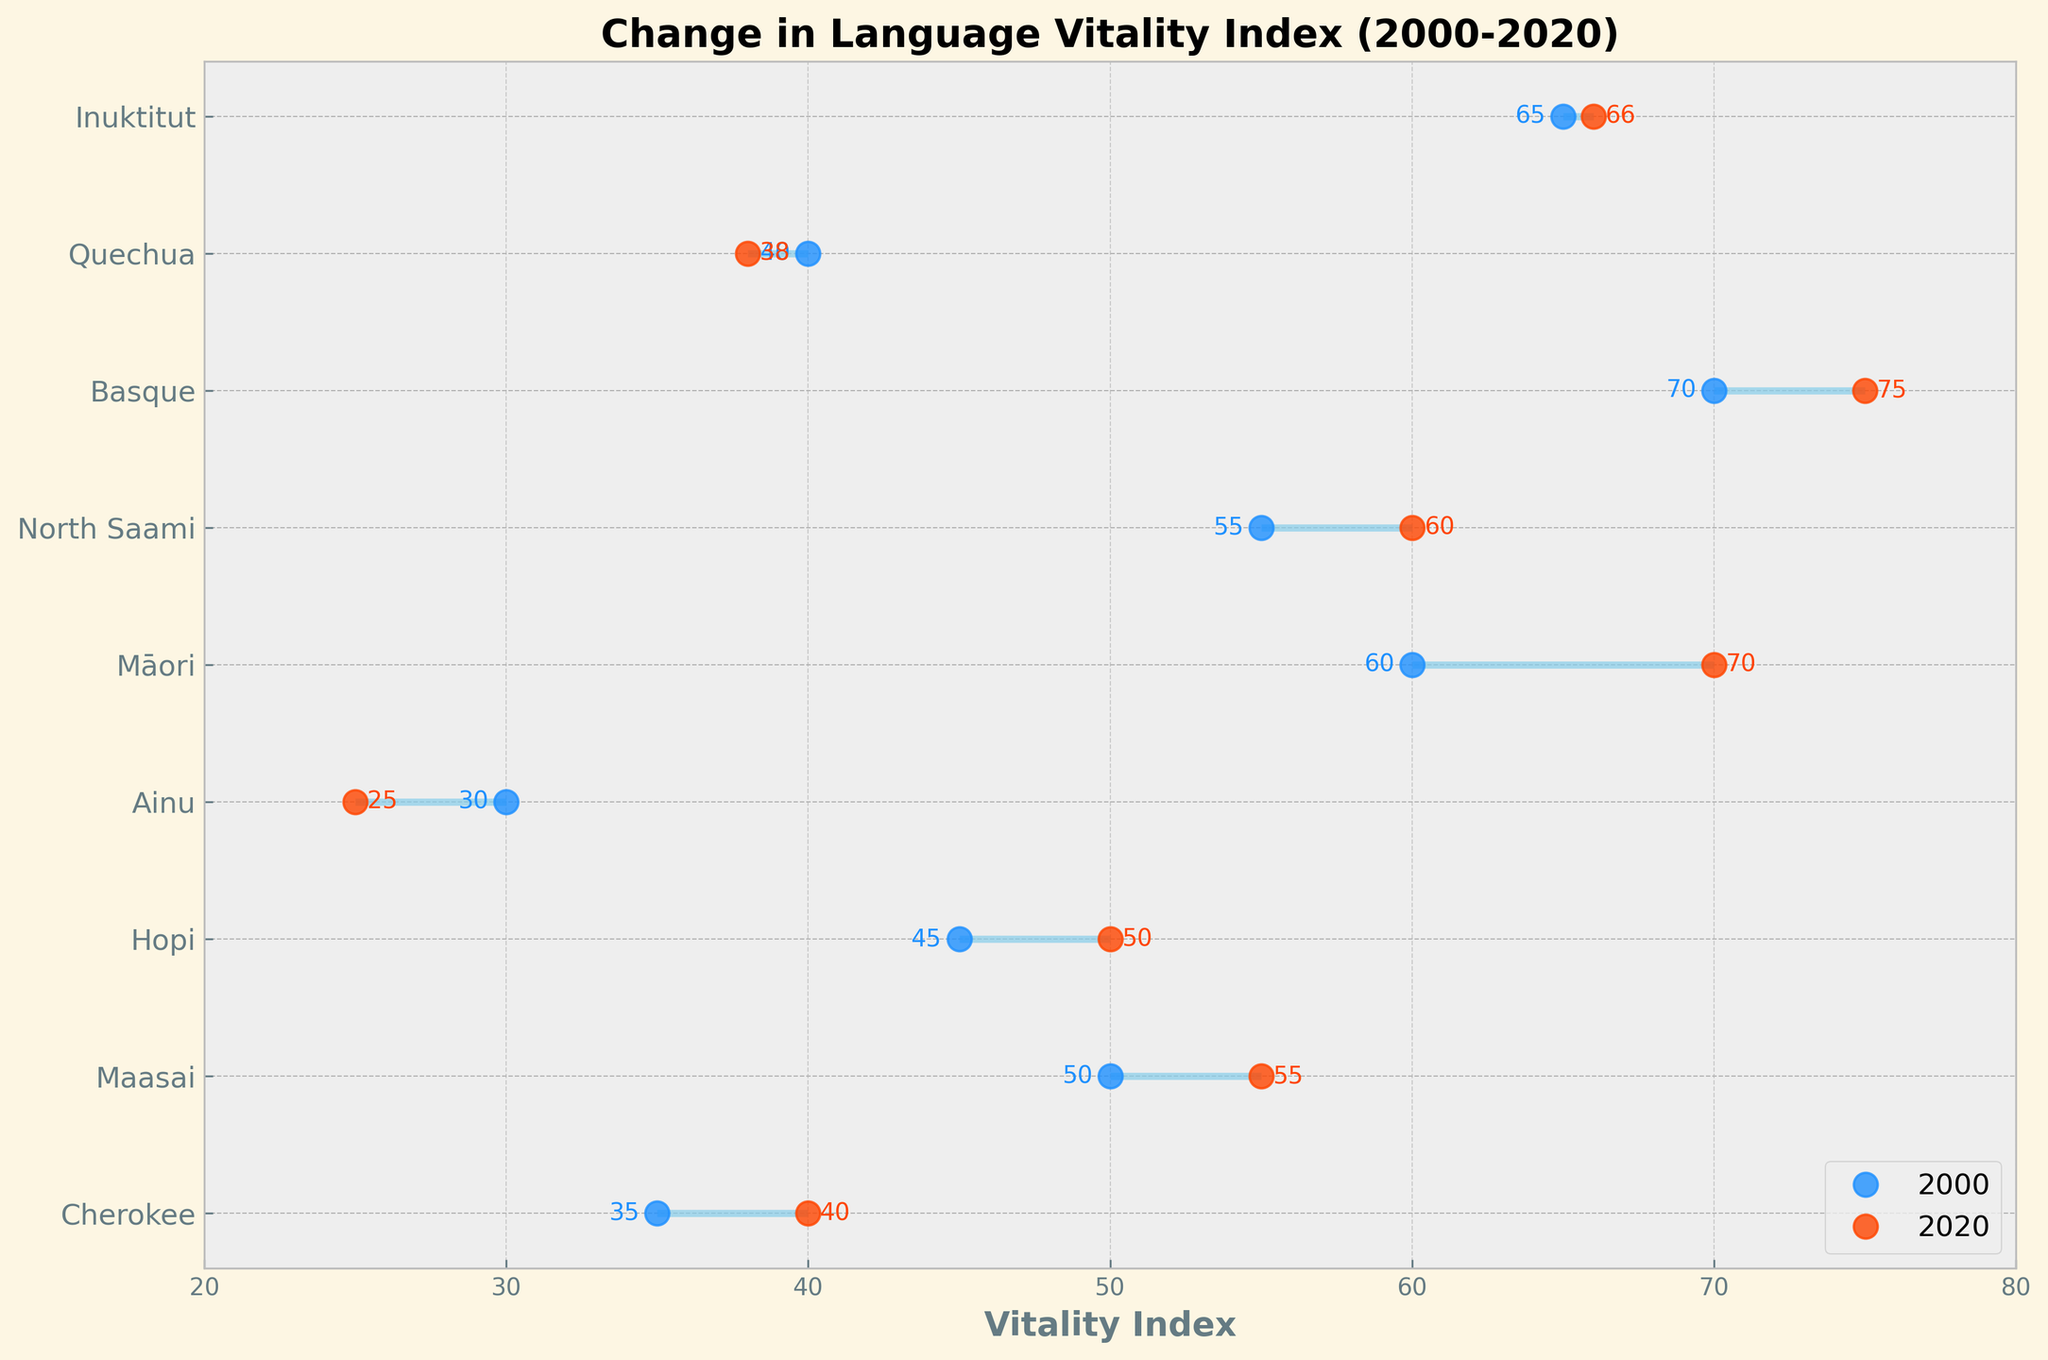Which community had the highest starting Vitality Index in 2000? Look at the 'Vitality Index (Start)' values on the left side of the dumbbell plot and find the highest value. The Basque community, with a value of 70, has the highest starting Vitality Index in 2000.
Answer: Basque Community What is the difference in the Vitality Index for the Ainu language between 2000 and 2020? Locate the Ainu language on the plot and compare the 'Vitality Index (Start)' of 30 and 'Vitality Index (End)' of 25. The difference is calculated as 30 - 25 = 5.
Answer: 5 Which language showed a decline in its Vitality Index over the 20 years? Examine the dumbbell plot and look for languages where the end vitality index is lower than the start vitality index. The Ainu and Quechua languages show a decline in their indices.
Answer: Ainu and Quechua Which community showed the largest increase in Vitality Index from 2000 to 2020? Calculate the increase for each community by subtracting the start index from the end index and compare these values. The Māori Community showed the largest increase from 60 to 70, which is an increase of 10 points.
Answer: Māori Community How many communities have an end Vitality Index greater than 60 in 2020? Look at the 'Vitality Index (End)' values and count the number of values greater than 60. The Māori Community, Basque Community, and Inuit People have end values greater than 60, making the count 3.
Answer: 3 Which language has the closest end Vitality Index to its start Vitality Index? Compare the differences between the start and end indices for each language. The language with the smallest difference is Inuktitut, with a start index of 65 and an end index of 66, a difference of 1.
Answer: Inuktitut What is the average start Vitality Index for all communities? Sum the 'Vitality Index (Start)' values and divide by the number of communities. (35 + 50 + 45 + 30 + 60 + 55 + 70 + 40 + 65) / 9 = 450 / 9.
Answer: 50 Among the listed languages, which one had the smallest change in its Vitality Index over the 20 years? Identify the language with the smallest absolute difference between the 'Start' and 'End' values. The Inuktitut language has the smallest change, with a difference of 1 (66 - 65).
Answer: Inuktitut 